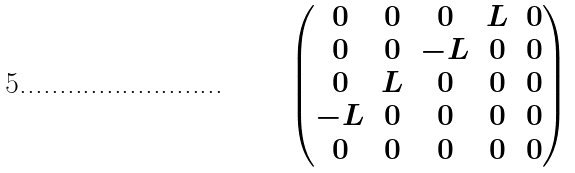<formula> <loc_0><loc_0><loc_500><loc_500>\begin{pmatrix} 0 & 0 & 0 & L & 0 \\ 0 & 0 & - L & 0 & 0 \\ 0 & L & 0 & 0 & 0 \\ - L & 0 & 0 & 0 & 0 \\ 0 & 0 & 0 & 0 & 0 \end{pmatrix}</formula> 